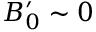Convert formula to latex. <formula><loc_0><loc_0><loc_500><loc_500>B _ { 0 } ^ { \prime } \sim 0</formula> 